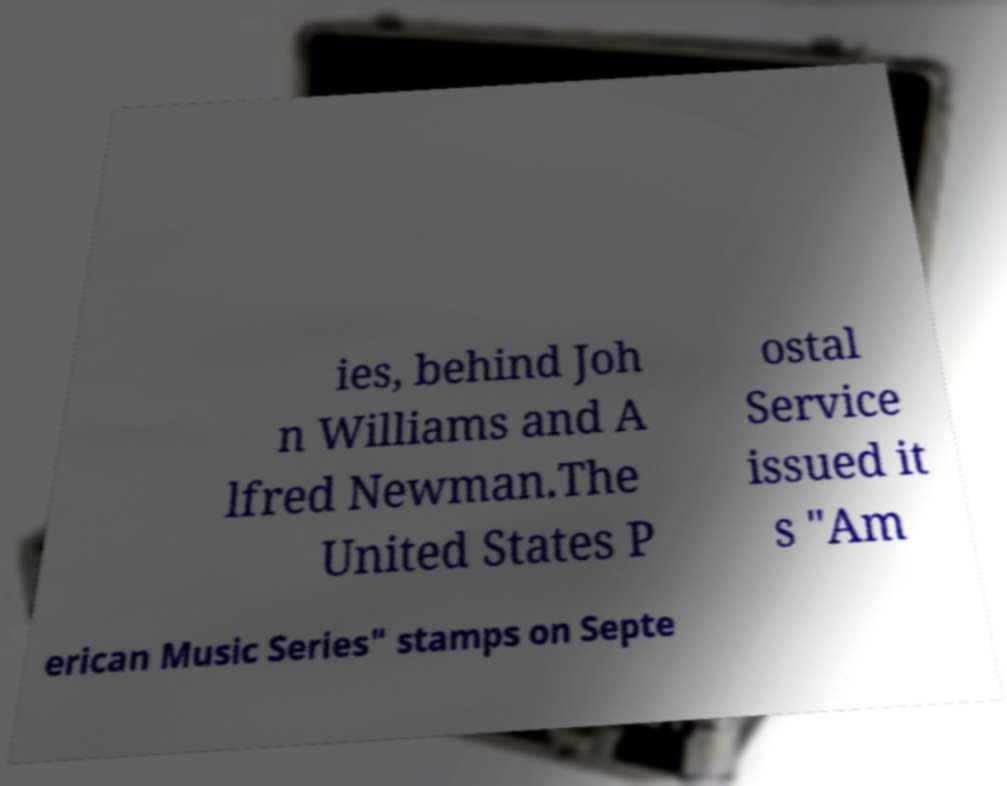Can you accurately transcribe the text from the provided image for me? ies, behind Joh n Williams and A lfred Newman.The United States P ostal Service issued it s "Am erican Music Series" stamps on Septe 